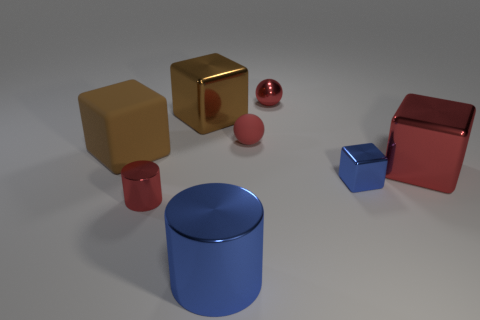Are there the same number of big objects that are to the right of the brown matte thing and large blue cylinders that are right of the big blue metal thing?
Give a very brief answer. No. Does the brown thing left of the tiny shiny cylinder have the same shape as the big red metal thing?
Offer a terse response. Yes. There is a red shiny ball; is its size the same as the blue object that is in front of the small red cylinder?
Keep it short and to the point. No. How many other things are the same color as the large matte thing?
Your answer should be compact. 1. Are there any cubes in front of the tiny rubber sphere?
Make the answer very short. Yes. How many things are brown rubber objects or big objects that are behind the small metallic cylinder?
Ensure brevity in your answer.  3. There is a large brown cube on the left side of the red cylinder; is there a tiny blue metal object on the right side of it?
Ensure brevity in your answer.  Yes. What is the shape of the large brown thing that is to the left of the tiny thing left of the large brown block behind the rubber block?
Ensure brevity in your answer.  Cube. The metallic thing that is both to the left of the big blue shiny cylinder and behind the big red shiny thing is what color?
Ensure brevity in your answer.  Brown. What shape is the small object that is in front of the small metallic block?
Offer a terse response. Cylinder. 